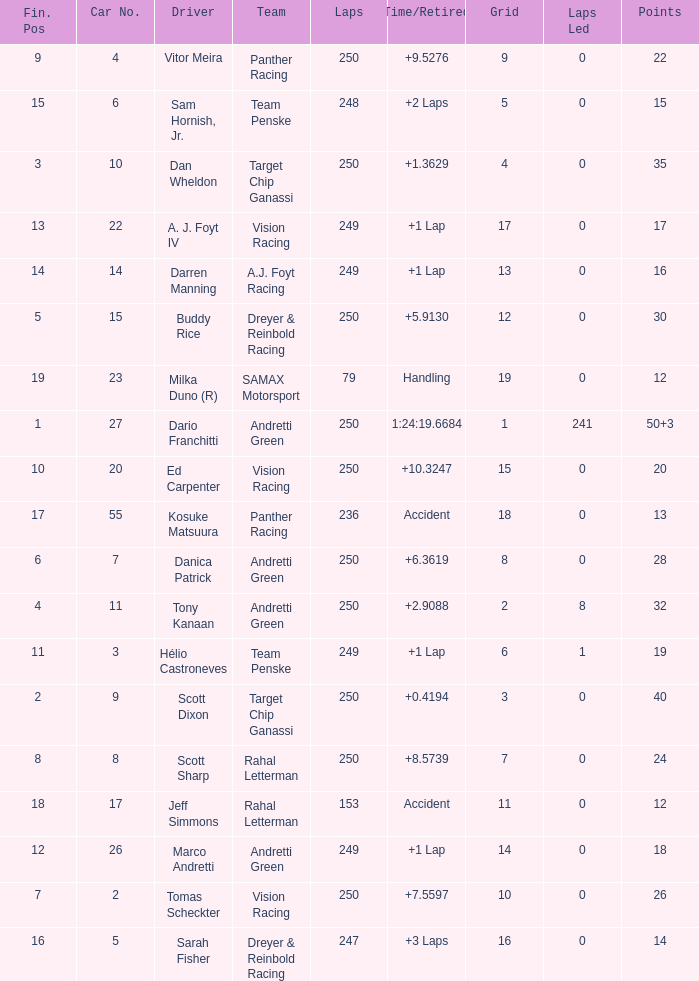Name the number of driver for fin pos of 19 1.0. 